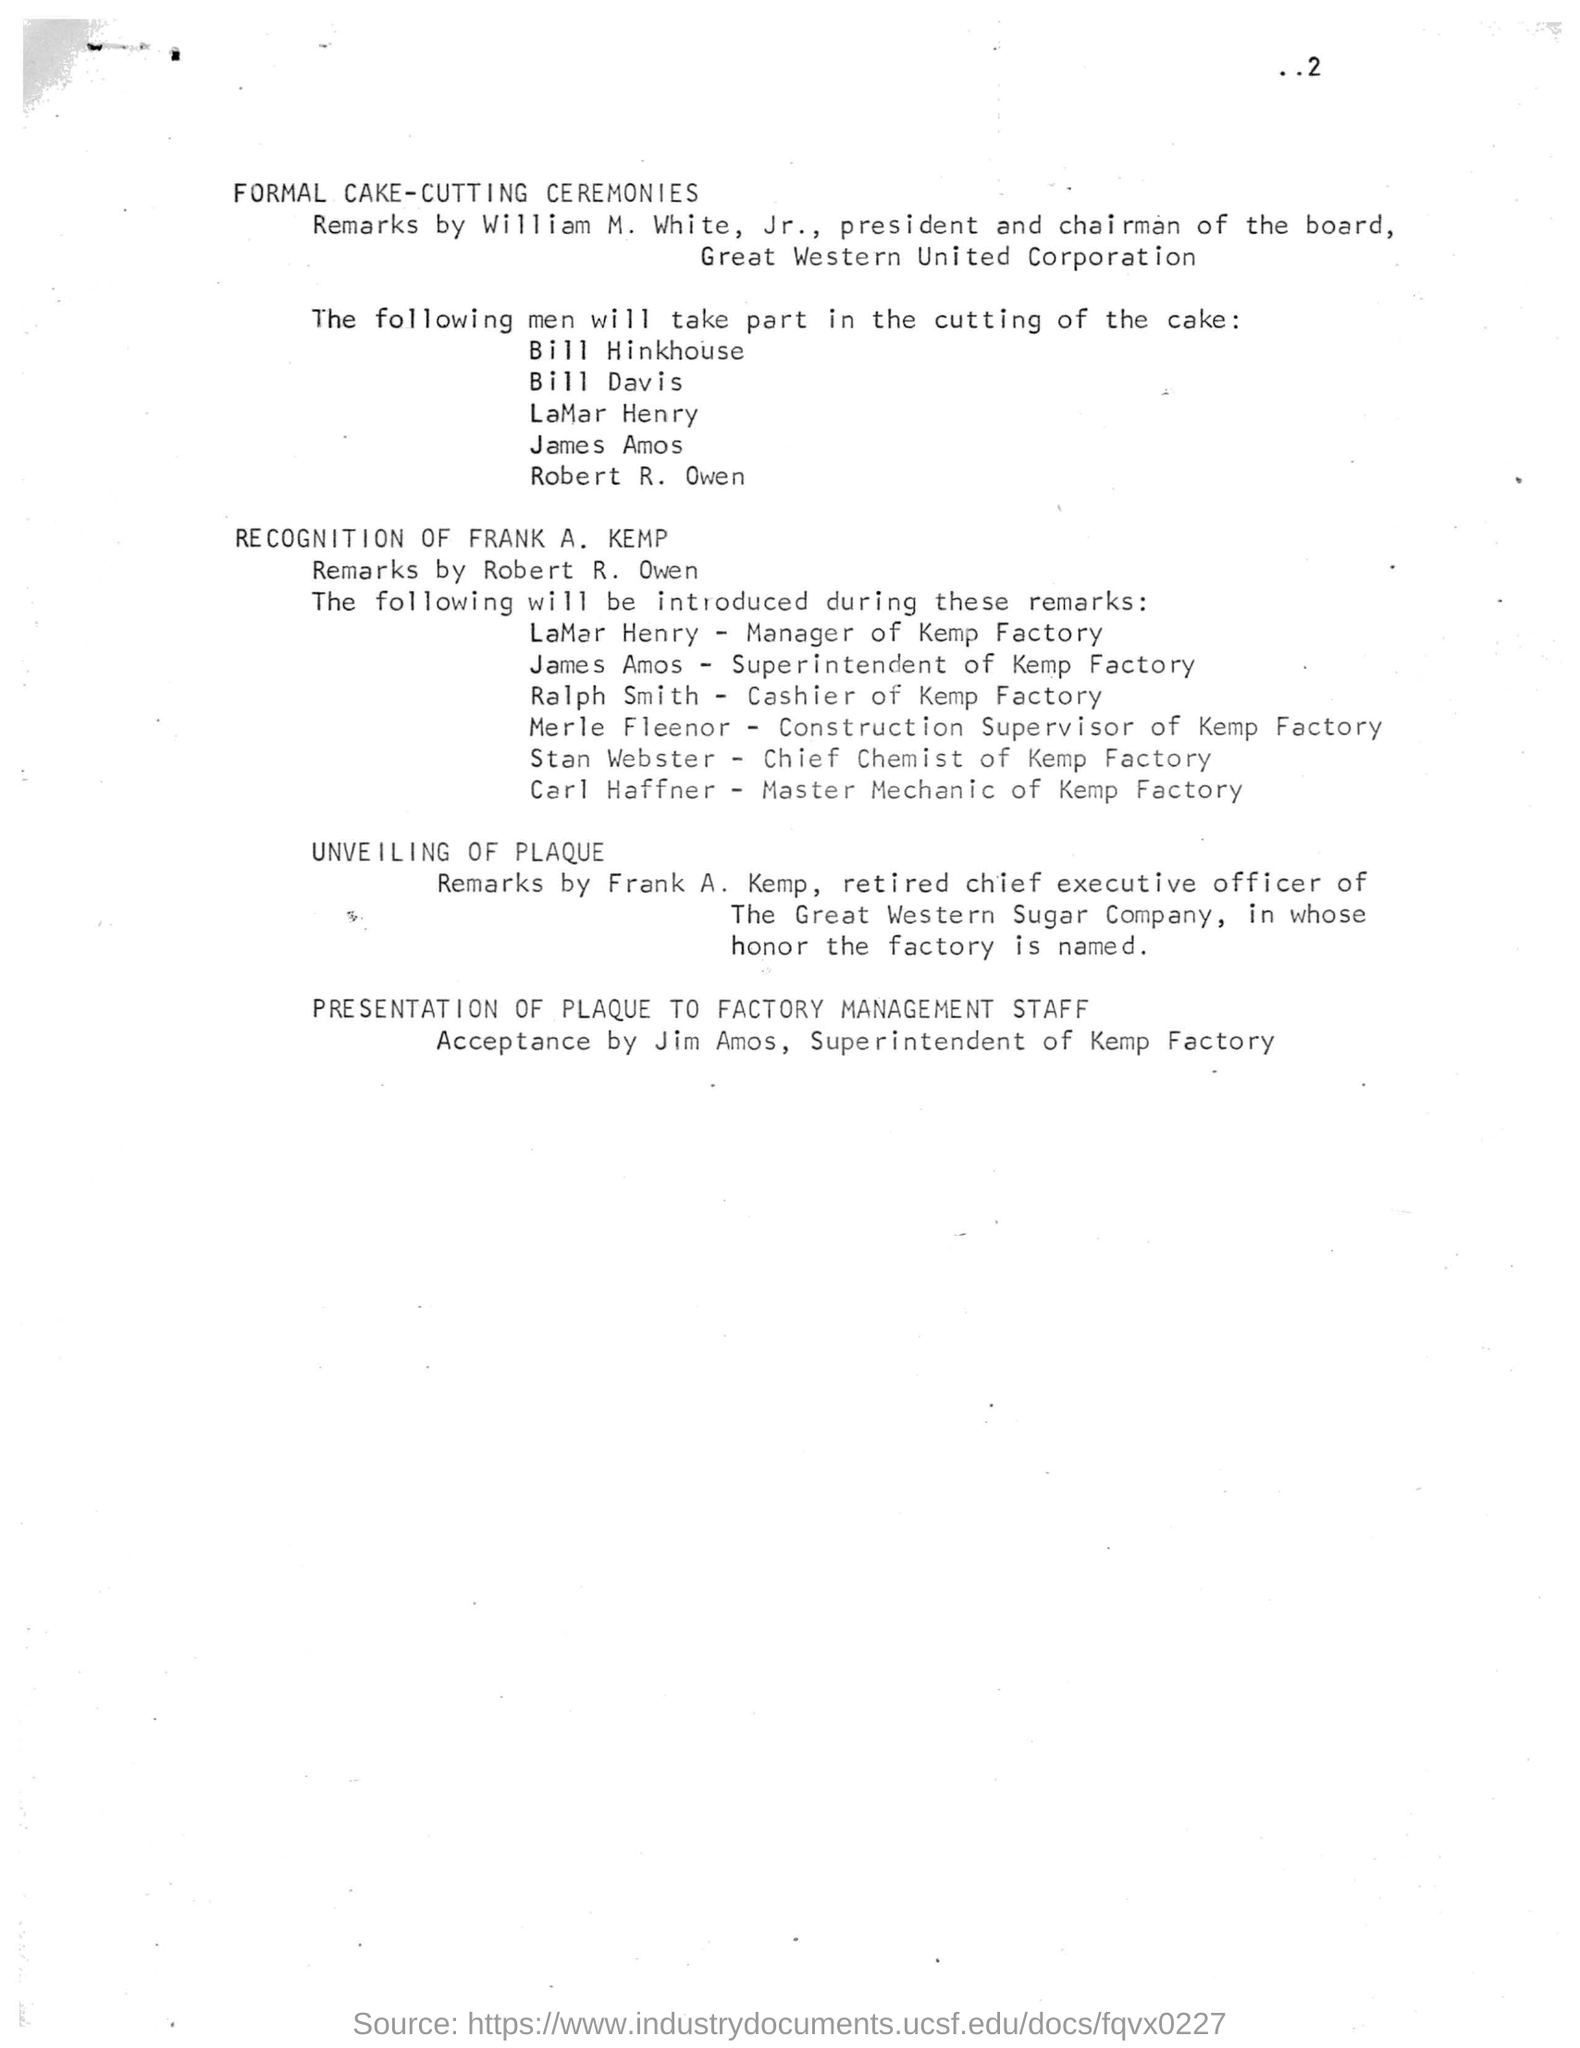Draw attention to some important aspects in this diagram. LaMar Henry is the manager of Kemp Factory. The Chief Chemist of Kemp Factory is Stan Webster. William M. White, Jr. is the president and chairman of the board of Great Western United Corporation. The factory is named in honor of Frank A. Kemp. 